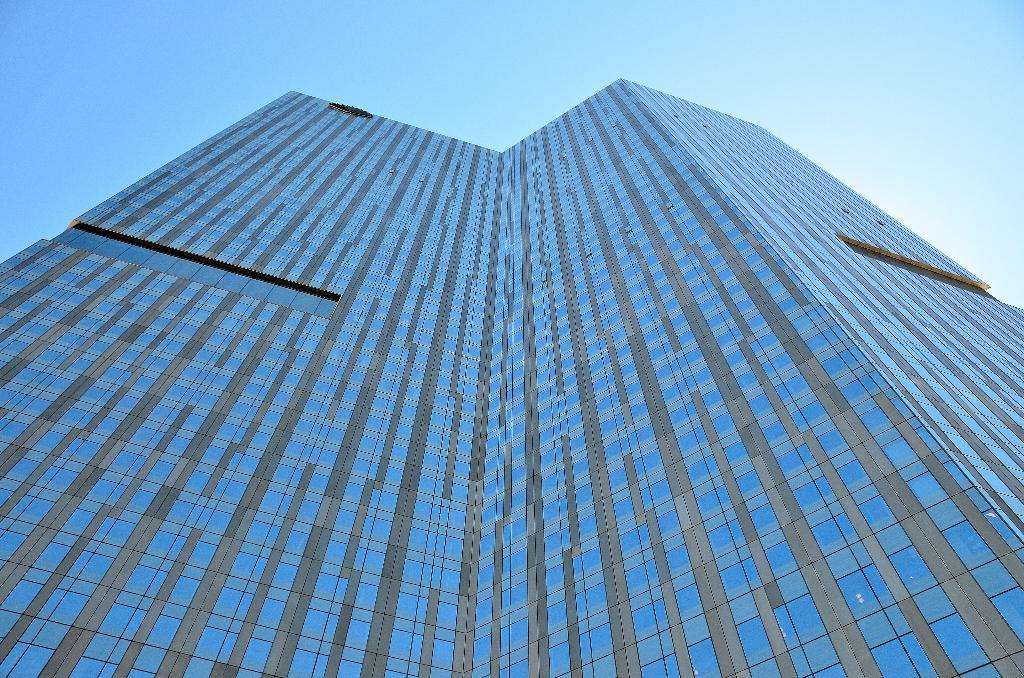What is the main subject in the center of the image? There is a building in the center of the image. What can be seen at the top of the image? The sky is visible at the top of the image. How does the honey taste in the image? There is no honey present in the image, so it cannot be tasted or described. 